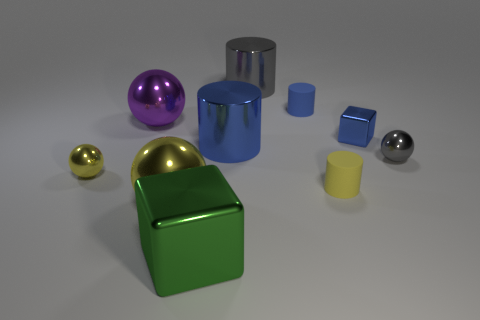What materials do these objects appear to be made of? The objects in the image appear to be made of a reflective material consistent with metals or polished plastics, each with a different vibrant color adding to the visual appeal. 